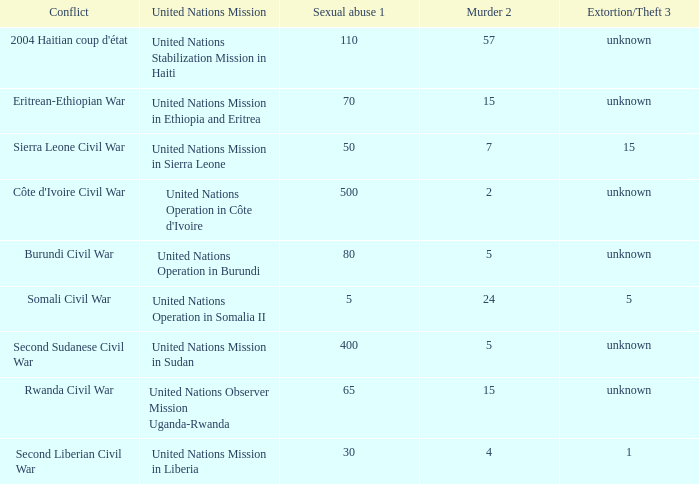What is the sexual abuse rate where the conflict is the Burundi Civil War? 80.0. Would you be able to parse every entry in this table? {'header': ['Conflict', 'United Nations Mission', 'Sexual abuse 1', 'Murder 2', 'Extortion/Theft 3'], 'rows': [["2004 Haitian coup d'état", 'United Nations Stabilization Mission in Haiti', '110', '57', 'unknown'], ['Eritrean-Ethiopian War', 'United Nations Mission in Ethiopia and Eritrea', '70', '15', 'unknown'], ['Sierra Leone Civil War', 'United Nations Mission in Sierra Leone', '50', '7', '15'], ["Côte d'Ivoire Civil War", "United Nations Operation in Côte d'Ivoire", '500', '2', 'unknown'], ['Burundi Civil War', 'United Nations Operation in Burundi', '80', '5', 'unknown'], ['Somali Civil War', 'United Nations Operation in Somalia II', '5', '24', '5'], ['Second Sudanese Civil War', 'United Nations Mission in Sudan', '400', '5', 'unknown'], ['Rwanda Civil War', 'United Nations Observer Mission Uganda-Rwanda', '65', '15', 'unknown'], ['Second Liberian Civil War', 'United Nations Mission in Liberia', '30', '4', '1']]} 